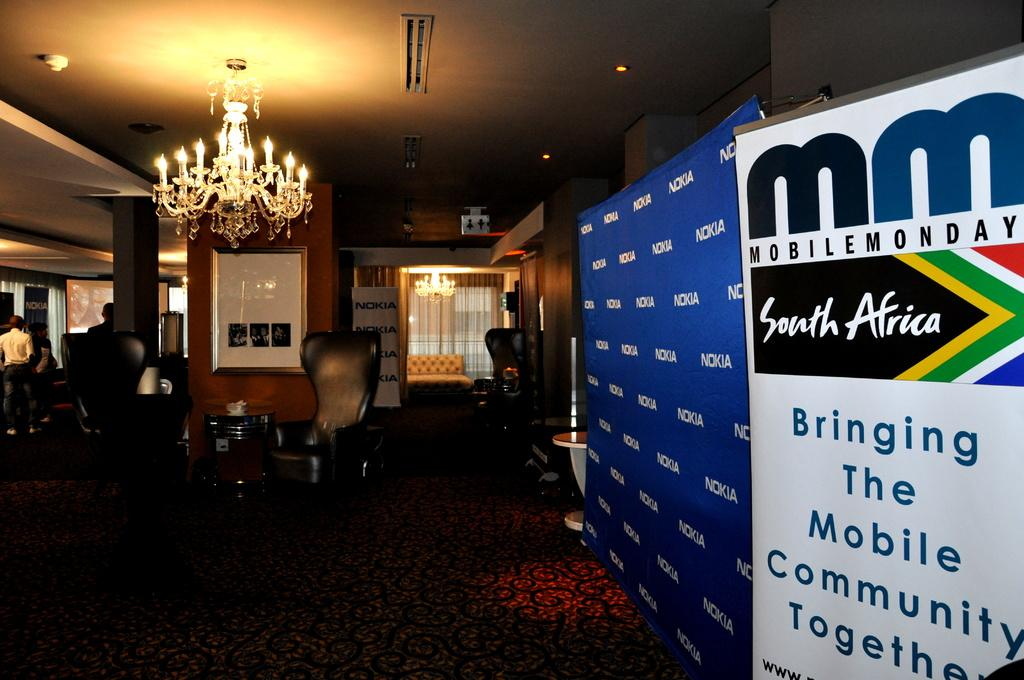<image>
Provide a brief description of the given image. A conference room in South Africa with a sign advertising Mobile Monday. 